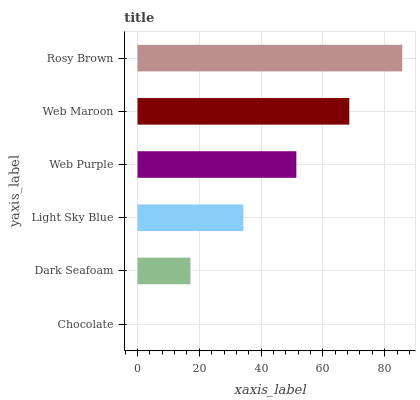Is Chocolate the minimum?
Answer yes or no. Yes. Is Rosy Brown the maximum?
Answer yes or no. Yes. Is Dark Seafoam the minimum?
Answer yes or no. No. Is Dark Seafoam the maximum?
Answer yes or no. No. Is Dark Seafoam greater than Chocolate?
Answer yes or no. Yes. Is Chocolate less than Dark Seafoam?
Answer yes or no. Yes. Is Chocolate greater than Dark Seafoam?
Answer yes or no. No. Is Dark Seafoam less than Chocolate?
Answer yes or no. No. Is Web Purple the high median?
Answer yes or no. Yes. Is Light Sky Blue the low median?
Answer yes or no. Yes. Is Web Maroon the high median?
Answer yes or no. No. Is Chocolate the low median?
Answer yes or no. No. 